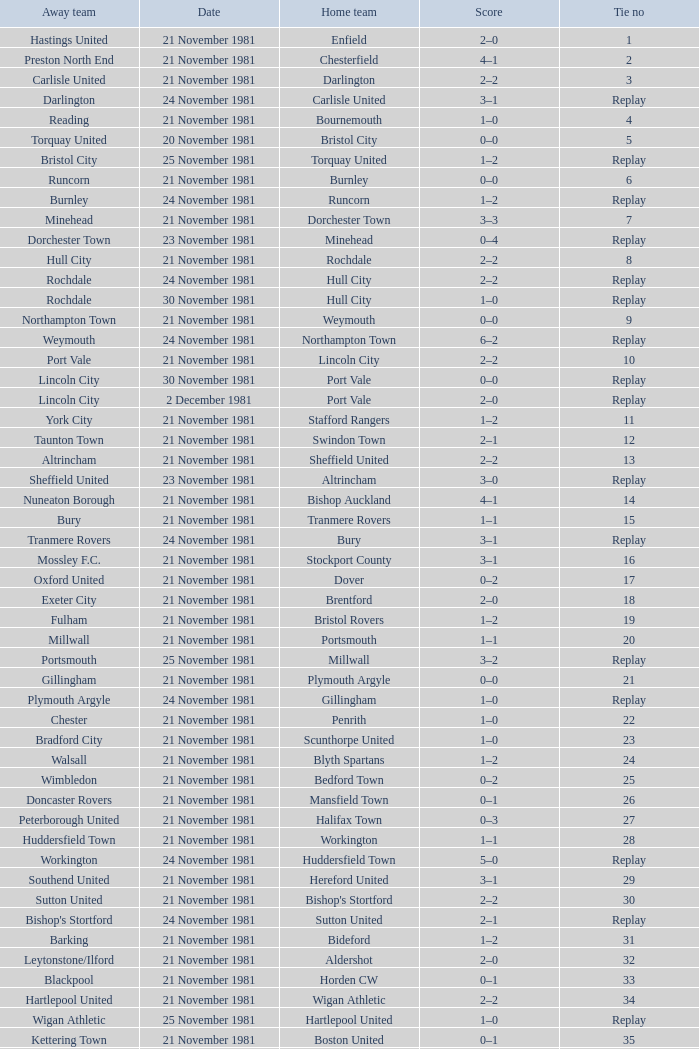On what date was tie number 4? 21 November 1981. Parse the table in full. {'header': ['Away team', 'Date', 'Home team', 'Score', 'Tie no'], 'rows': [['Hastings United', '21 November 1981', 'Enfield', '2–0', '1'], ['Preston North End', '21 November 1981', 'Chesterfield', '4–1', '2'], ['Carlisle United', '21 November 1981', 'Darlington', '2–2', '3'], ['Darlington', '24 November 1981', 'Carlisle United', '3–1', 'Replay'], ['Reading', '21 November 1981', 'Bournemouth', '1–0', '4'], ['Torquay United', '20 November 1981', 'Bristol City', '0–0', '5'], ['Bristol City', '25 November 1981', 'Torquay United', '1–2', 'Replay'], ['Runcorn', '21 November 1981', 'Burnley', '0–0', '6'], ['Burnley', '24 November 1981', 'Runcorn', '1–2', 'Replay'], ['Minehead', '21 November 1981', 'Dorchester Town', '3–3', '7'], ['Dorchester Town', '23 November 1981', 'Minehead', '0–4', 'Replay'], ['Hull City', '21 November 1981', 'Rochdale', '2–2', '8'], ['Rochdale', '24 November 1981', 'Hull City', '2–2', 'Replay'], ['Rochdale', '30 November 1981', 'Hull City', '1–0', 'Replay'], ['Northampton Town', '21 November 1981', 'Weymouth', '0–0', '9'], ['Weymouth', '24 November 1981', 'Northampton Town', '6–2', 'Replay'], ['Port Vale', '21 November 1981', 'Lincoln City', '2–2', '10'], ['Lincoln City', '30 November 1981', 'Port Vale', '0–0', 'Replay'], ['Lincoln City', '2 December 1981', 'Port Vale', '2–0', 'Replay'], ['York City', '21 November 1981', 'Stafford Rangers', '1–2', '11'], ['Taunton Town', '21 November 1981', 'Swindon Town', '2–1', '12'], ['Altrincham', '21 November 1981', 'Sheffield United', '2–2', '13'], ['Sheffield United', '23 November 1981', 'Altrincham', '3–0', 'Replay'], ['Nuneaton Borough', '21 November 1981', 'Bishop Auckland', '4–1', '14'], ['Bury', '21 November 1981', 'Tranmere Rovers', '1–1', '15'], ['Tranmere Rovers', '24 November 1981', 'Bury', '3–1', 'Replay'], ['Mossley F.C.', '21 November 1981', 'Stockport County', '3–1', '16'], ['Oxford United', '21 November 1981', 'Dover', '0–2', '17'], ['Exeter City', '21 November 1981', 'Brentford', '2–0', '18'], ['Fulham', '21 November 1981', 'Bristol Rovers', '1–2', '19'], ['Millwall', '21 November 1981', 'Portsmouth', '1–1', '20'], ['Portsmouth', '25 November 1981', 'Millwall', '3–2', 'Replay'], ['Gillingham', '21 November 1981', 'Plymouth Argyle', '0–0', '21'], ['Plymouth Argyle', '24 November 1981', 'Gillingham', '1–0', 'Replay'], ['Chester', '21 November 1981', 'Penrith', '1–0', '22'], ['Bradford City', '21 November 1981', 'Scunthorpe United', '1–0', '23'], ['Walsall', '21 November 1981', 'Blyth Spartans', '1–2', '24'], ['Wimbledon', '21 November 1981', 'Bedford Town', '0–2', '25'], ['Doncaster Rovers', '21 November 1981', 'Mansfield Town', '0–1', '26'], ['Peterborough United', '21 November 1981', 'Halifax Town', '0–3', '27'], ['Huddersfield Town', '21 November 1981', 'Workington', '1–1', '28'], ['Workington', '24 November 1981', 'Huddersfield Town', '5–0', 'Replay'], ['Southend United', '21 November 1981', 'Hereford United', '3–1', '29'], ['Sutton United', '21 November 1981', "Bishop's Stortford", '2–2', '30'], ["Bishop's Stortford", '24 November 1981', 'Sutton United', '2–1', 'Replay'], ['Barking', '21 November 1981', 'Bideford', '1–2', '31'], ['Leytonstone/Ilford', '21 November 1981', 'Aldershot', '2–0', '32'], ['Blackpool', '21 November 1981', 'Horden CW', '0–1', '33'], ['Hartlepool United', '21 November 1981', 'Wigan Athletic', '2–2', '34'], ['Wigan Athletic', '25 November 1981', 'Hartlepool United', '1–0', 'Replay'], ['Kettering Town', '21 November 1981', 'Boston United', '0–1', '35'], ['Barnet', '21 November 1981', 'Harlow Town', '0–0', '36'], ['Harlow Town', '24 November 1981', 'Barnet', '1–0', 'Replay'], ['Newport County', '21 November 1981', 'Colchester United', '2–0', '37'], ['Wycombe Wanderers', '21 November 1981', 'Hendon', '1–1', '38'], ['Hendon', '24 November 1981', 'Wycombe Wanderers', '2–0', 'Replay'], ['Yeovil Town', '21 November 1981', 'Dagenham', '2–2', '39'], ['Dagenham', '25 November 1981', 'Yeovil Town', '0–1', 'Replay'], ['Crewe Alexandra', '21 November 1981', 'Willenhall Town', '0–1', '40']]} 